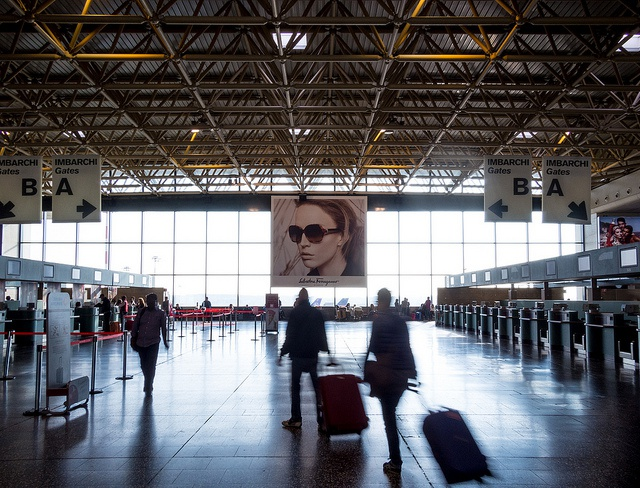Describe the objects in this image and their specific colors. I can see people in black and gray tones, people in black, gray, and maroon tones, people in black, gray, and darkblue tones, suitcase in black, blue, and gray tones, and suitcase in black and gray tones in this image. 